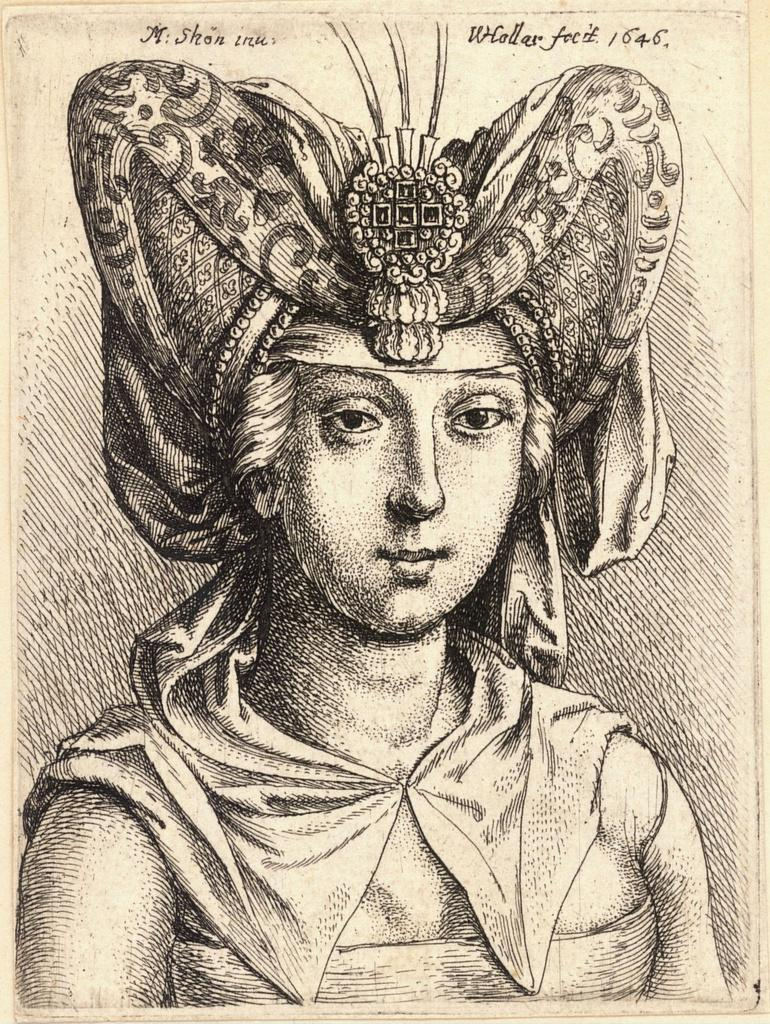What is the main subject of the image? The main subject of the image is a person. What else can be seen on the image besides the person? There is text and numbers on the poster. Where is the cave located in the image? There is no cave present in the image. What type of activity is the person engaged in within the image? The image is an art of a person, but there is no specific activity depicted. 